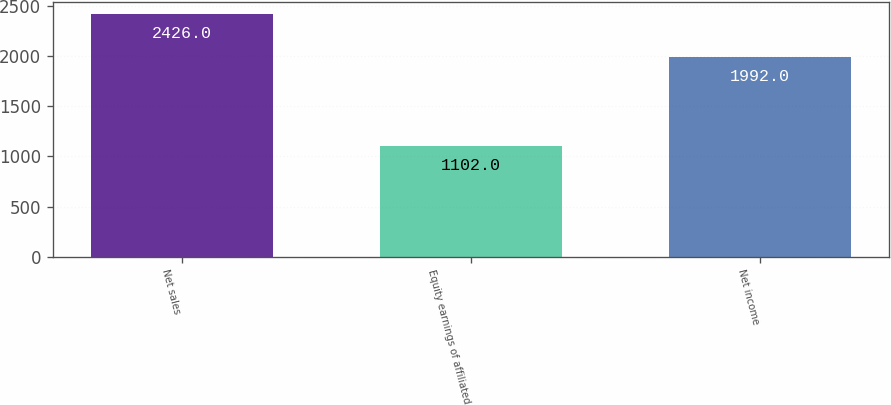Convert chart. <chart><loc_0><loc_0><loc_500><loc_500><bar_chart><fcel>Net sales<fcel>Equity earnings of affiliated<fcel>Net income<nl><fcel>2426<fcel>1102<fcel>1992<nl></chart> 